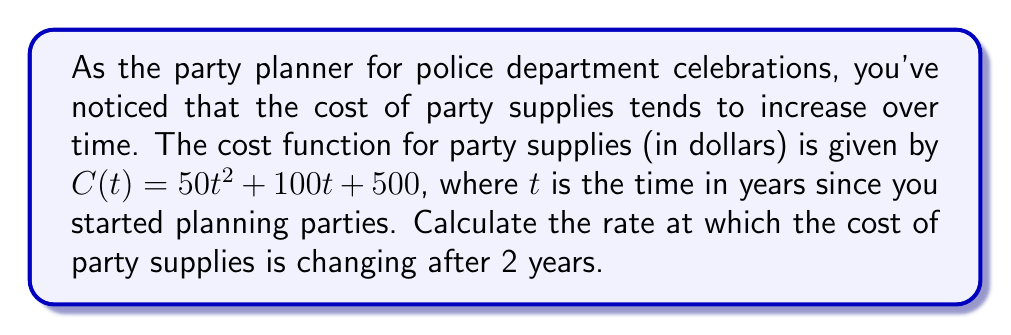Show me your answer to this math problem. To find the rate of change in party supplies cost over time, we need to calculate the derivative of the cost function $C(t)$ and then evaluate it at $t = 2$ years.

Step 1: Find the derivative of $C(t)$.
$$C(t) = 50t^2 + 100t + 500$$
$$\frac{d}{dt}C(t) = \frac{d}{dt}(50t^2) + \frac{d}{dt}(100t) + \frac{d}{dt}(500)$$
$$C'(t) = 100t + 100 + 0$$
$$C'(t) = 100t + 100$$

Step 2: Evaluate the derivative at $t = 2$ years.
$$C'(2) = 100(2) + 100$$
$$C'(2) = 200 + 100$$
$$C'(2) = 300$$

The rate of change after 2 years is 300 dollars per year.
Answer: $300$ dollars/year 